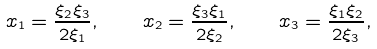<formula> <loc_0><loc_0><loc_500><loc_500>x _ { 1 } = \frac { \xi _ { 2 } \xi _ { 3 } } { 2 \xi _ { 1 } } , \quad x _ { 2 } = \frac { \xi _ { 3 } \xi _ { 1 } } { 2 \xi _ { 2 } } , \quad x _ { 3 } = \frac { \xi _ { 1 } \xi _ { 2 } } { 2 \xi _ { 3 } } ,</formula> 